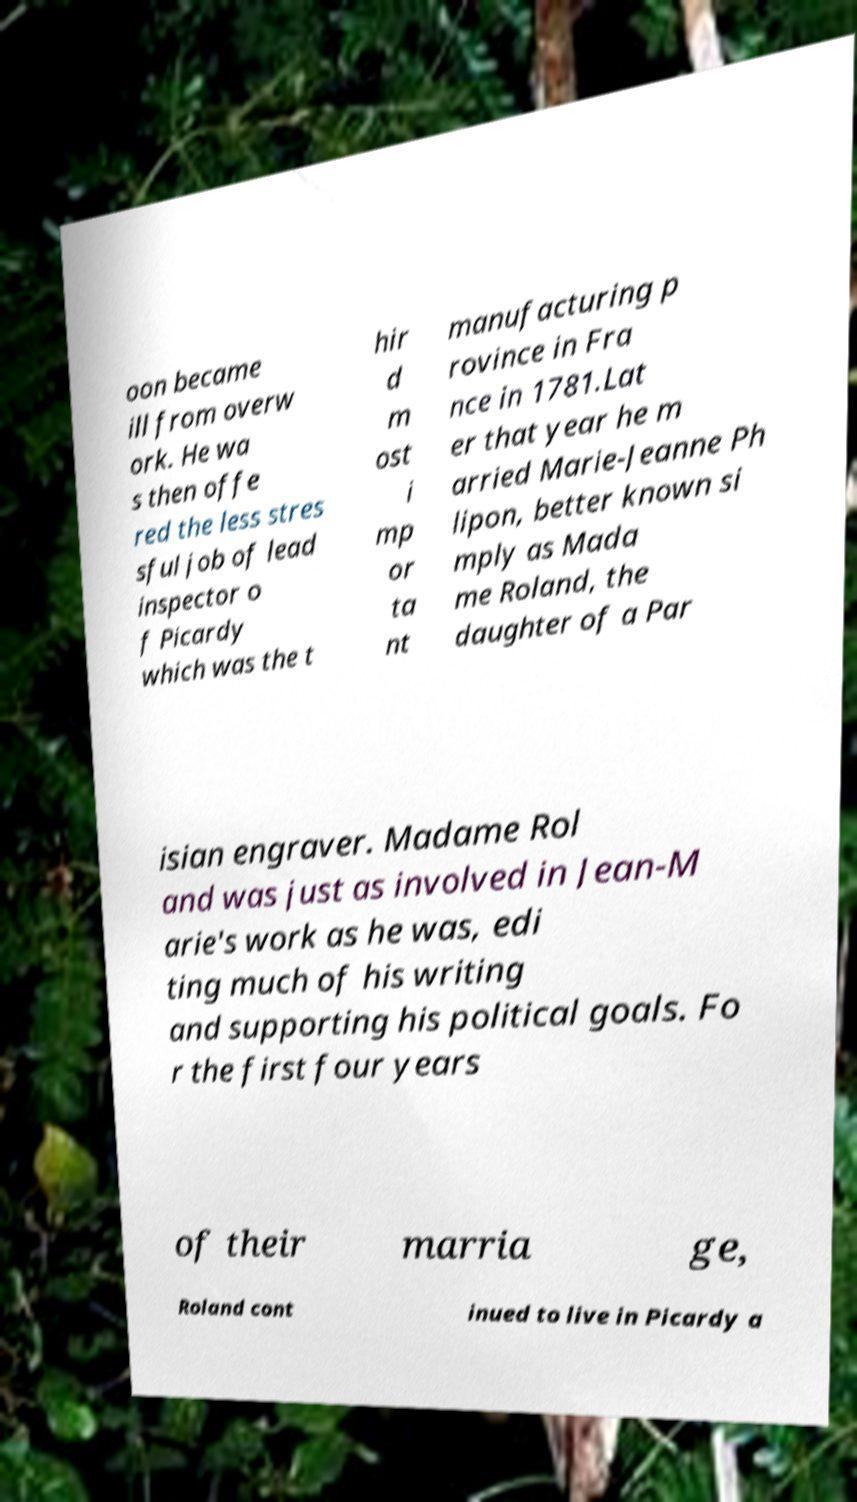Could you extract and type out the text from this image? oon became ill from overw ork. He wa s then offe red the less stres sful job of lead inspector o f Picardy which was the t hir d m ost i mp or ta nt manufacturing p rovince in Fra nce in 1781.Lat er that year he m arried Marie-Jeanne Ph lipon, better known si mply as Mada me Roland, the daughter of a Par isian engraver. Madame Rol and was just as involved in Jean-M arie's work as he was, edi ting much of his writing and supporting his political goals. Fo r the first four years of their marria ge, Roland cont inued to live in Picardy a 